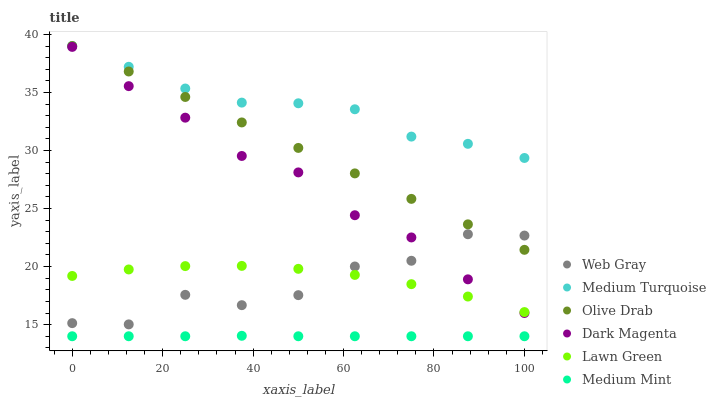Does Medium Mint have the minimum area under the curve?
Answer yes or no. Yes. Does Medium Turquoise have the maximum area under the curve?
Answer yes or no. Yes. Does Lawn Green have the minimum area under the curve?
Answer yes or no. No. Does Lawn Green have the maximum area under the curve?
Answer yes or no. No. Is Olive Drab the smoothest?
Answer yes or no. Yes. Is Web Gray the roughest?
Answer yes or no. Yes. Is Lawn Green the smoothest?
Answer yes or no. No. Is Lawn Green the roughest?
Answer yes or no. No. Does Medium Mint have the lowest value?
Answer yes or no. Yes. Does Lawn Green have the lowest value?
Answer yes or no. No. Does Olive Drab have the highest value?
Answer yes or no. Yes. Does Lawn Green have the highest value?
Answer yes or no. No. Is Lawn Green less than Olive Drab?
Answer yes or no. Yes. Is Medium Turquoise greater than Web Gray?
Answer yes or no. Yes. Does Web Gray intersect Lawn Green?
Answer yes or no. Yes. Is Web Gray less than Lawn Green?
Answer yes or no. No. Is Web Gray greater than Lawn Green?
Answer yes or no. No. Does Lawn Green intersect Olive Drab?
Answer yes or no. No. 